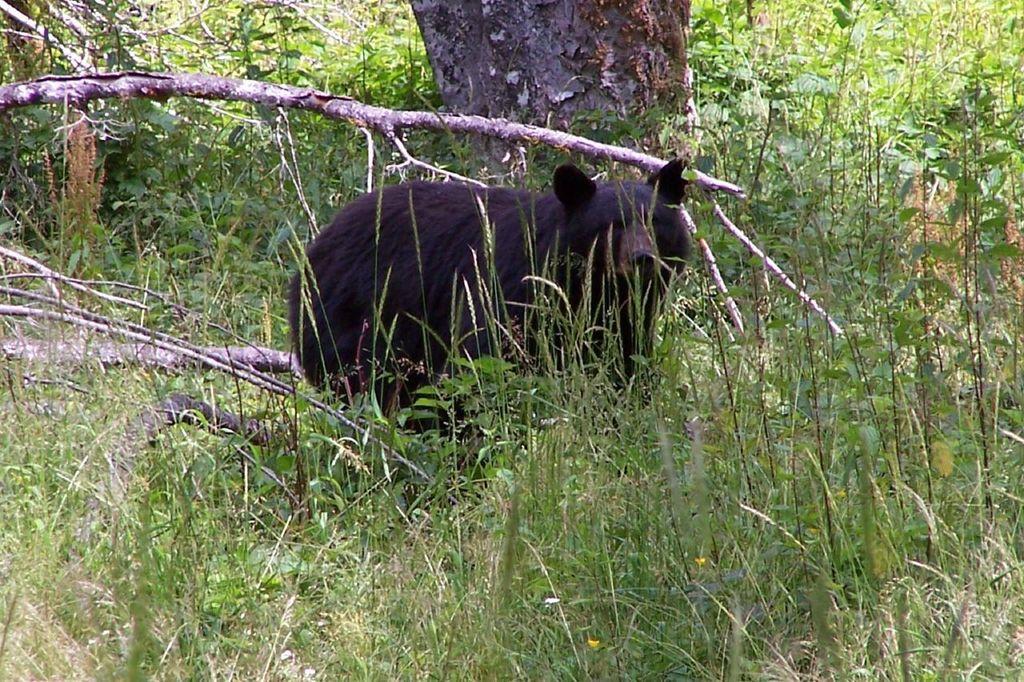How would you summarize this image in a sentence or two? In the picture I can see a bear standing in the grass, here I can see small plants and trees in the background. 